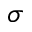<formula> <loc_0><loc_0><loc_500><loc_500>\sigma</formula> 